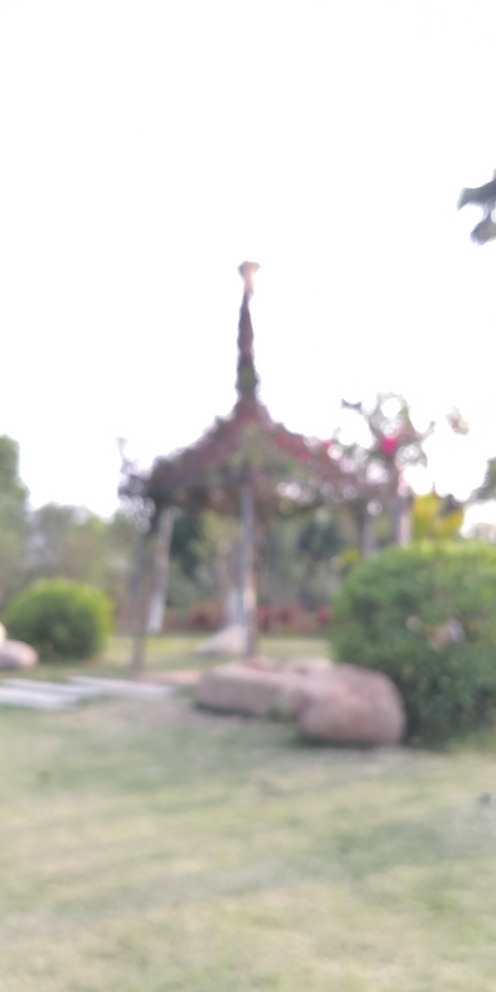Would you say this photo has artistic value despite the focus issue? Art is subjective. Some might find the blurred aesthetic creates a dream-like quality or evokes a feeling of mystery, imparting artistic value. For others, the lack of clarity could detract from any potential artistic appeal. 